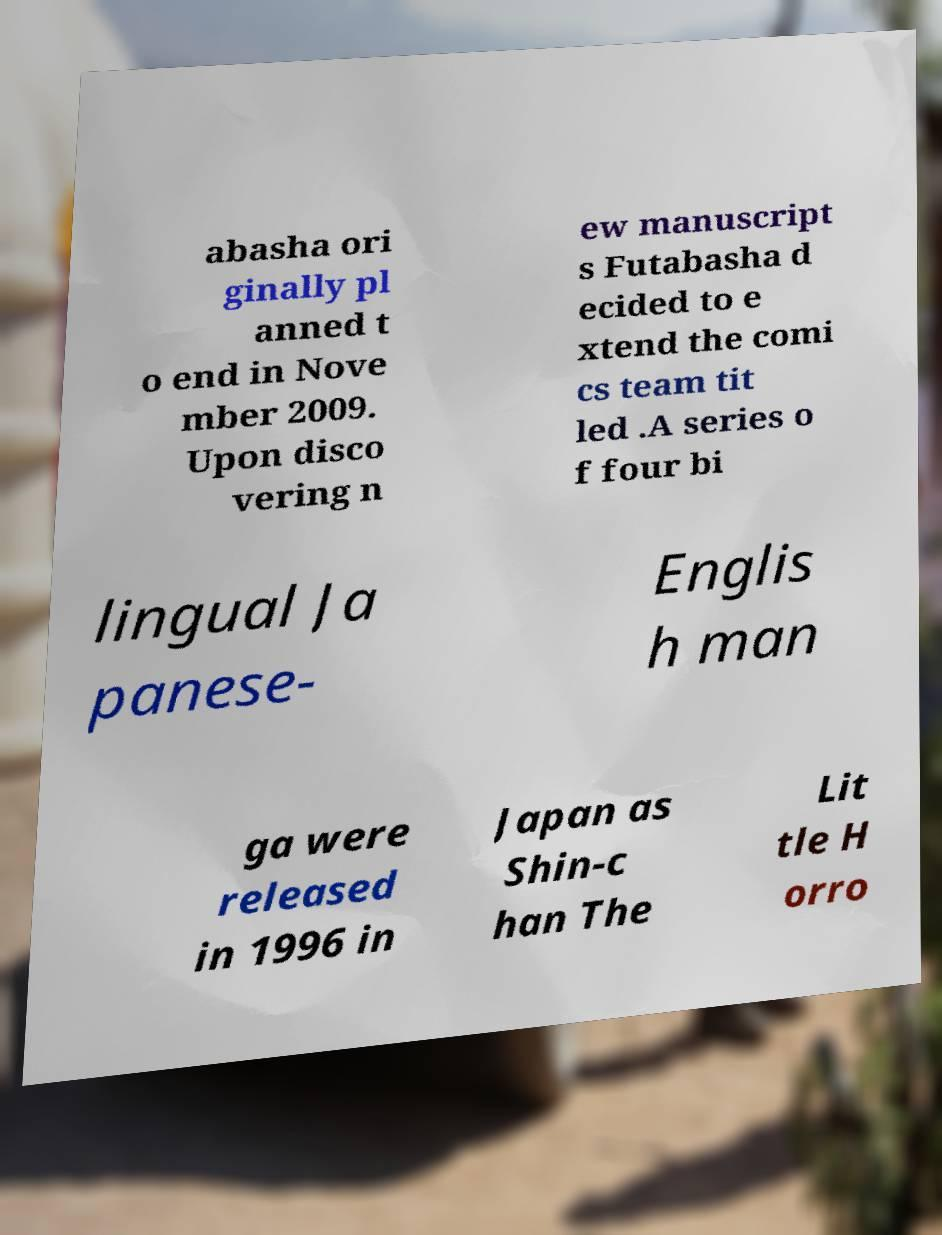Can you accurately transcribe the text from the provided image for me? abasha ori ginally pl anned t o end in Nove mber 2009. Upon disco vering n ew manuscript s Futabasha d ecided to e xtend the comi cs team tit led .A series o f four bi lingual Ja panese- Englis h man ga were released in 1996 in Japan as Shin-c han The Lit tle H orro 